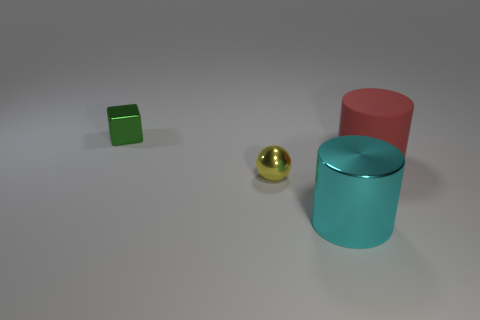There is another object that is the same shape as the big cyan shiny thing; what material is it?
Make the answer very short. Rubber. What number of things are cyan objects or large cylinders in front of the yellow shiny object?
Offer a very short reply. 1. Is the size of the red rubber cylinder the same as the thing in front of the small ball?
Provide a short and direct response. Yes. How many cylinders are either red rubber objects or small red things?
Offer a terse response. 1. How many things are to the right of the metallic cube and to the left of the large shiny cylinder?
Give a very brief answer. 1. What number of other things are the same color as the rubber object?
Keep it short and to the point. 0. There is a tiny shiny object in front of the tiny green shiny object; what shape is it?
Provide a succinct answer. Sphere. Is the tiny green block made of the same material as the red cylinder?
Keep it short and to the point. No. There is a cyan metal thing; how many green shiny blocks are behind it?
Give a very brief answer. 1. What is the shape of the small shiny thing to the left of the tiny object in front of the green object?
Ensure brevity in your answer.  Cube. 